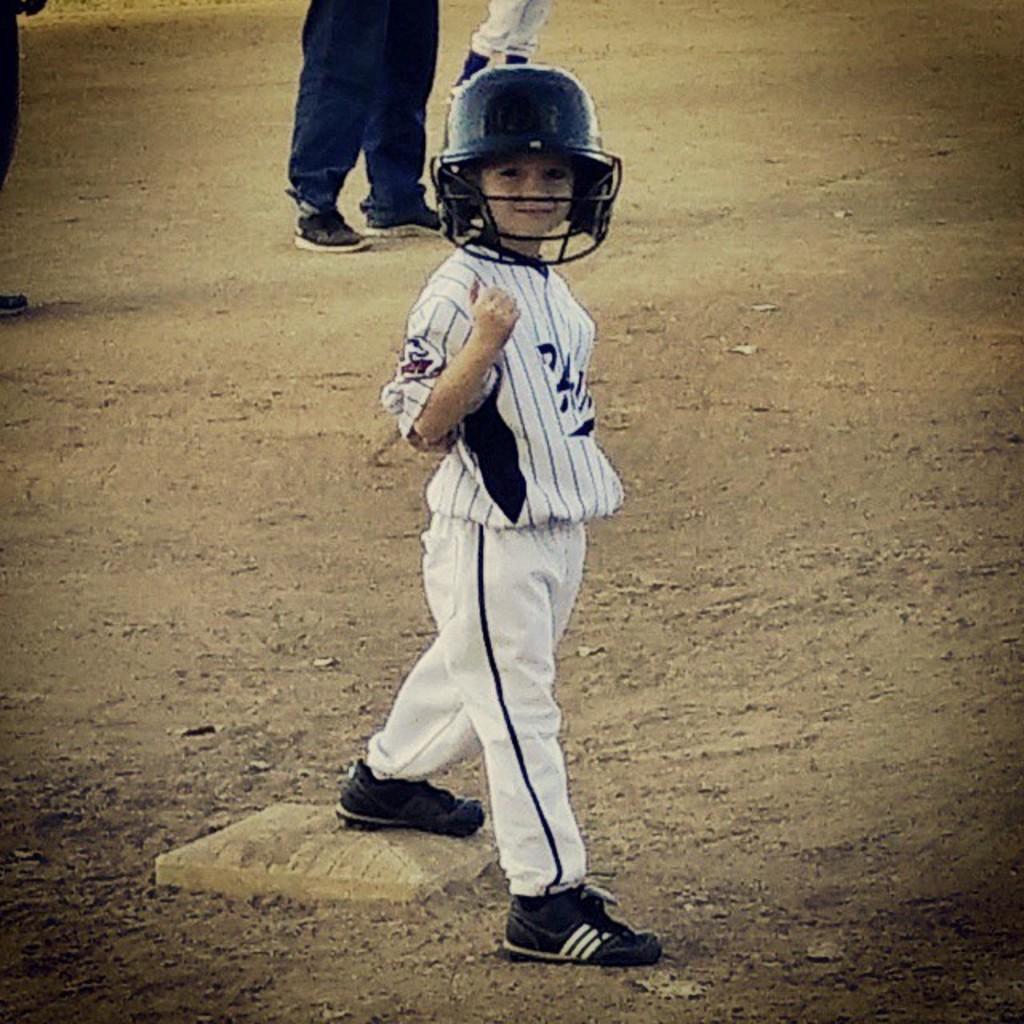Please provide a concise description of this image. In the picture I can see a boy is standing on the ground and wearing a helmet, white clothes and shoes. In the background I can see people are standing on the ground. 